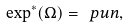<formula> <loc_0><loc_0><loc_500><loc_500>\exp ^ { * } ( \Omega ) = \ p u n ,</formula> 